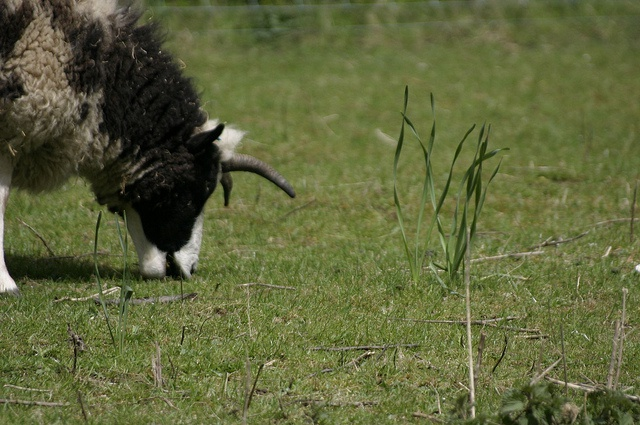Describe the objects in this image and their specific colors. I can see a sheep in black, gray, and darkgreen tones in this image. 